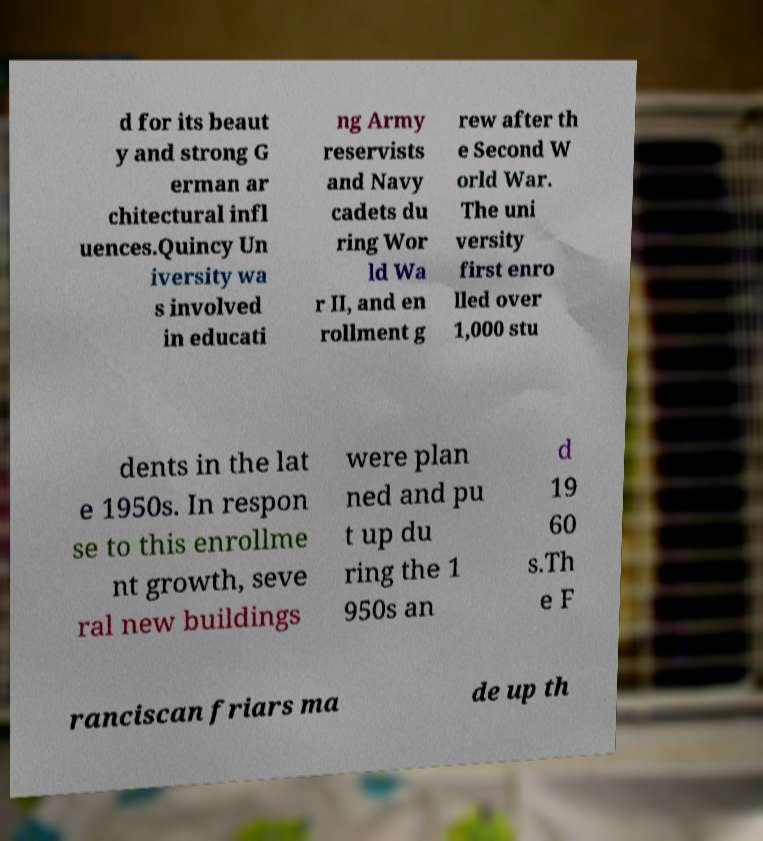Please identify and transcribe the text found in this image. d for its beaut y and strong G erman ar chitectural infl uences.Quincy Un iversity wa s involved in educati ng Army reservists and Navy cadets du ring Wor ld Wa r II, and en rollment g rew after th e Second W orld War. The uni versity first enro lled over 1,000 stu dents in the lat e 1950s. In respon se to this enrollme nt growth, seve ral new buildings were plan ned and pu t up du ring the 1 950s an d 19 60 s.Th e F ranciscan friars ma de up th 